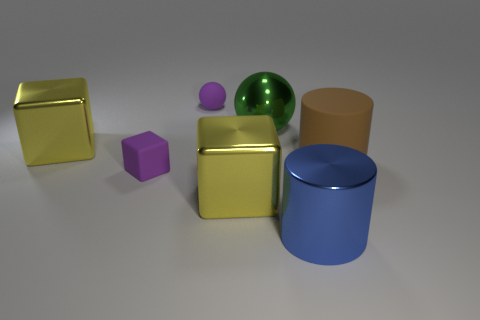Subtract all cyan blocks. Subtract all gray cylinders. How many blocks are left? 3 Add 1 balls. How many objects exist? 8 Subtract all spheres. How many objects are left? 5 Subtract all yellow matte balls. Subtract all spheres. How many objects are left? 5 Add 7 cylinders. How many cylinders are left? 9 Add 6 small blocks. How many small blocks exist? 7 Subtract 0 blue spheres. How many objects are left? 7 